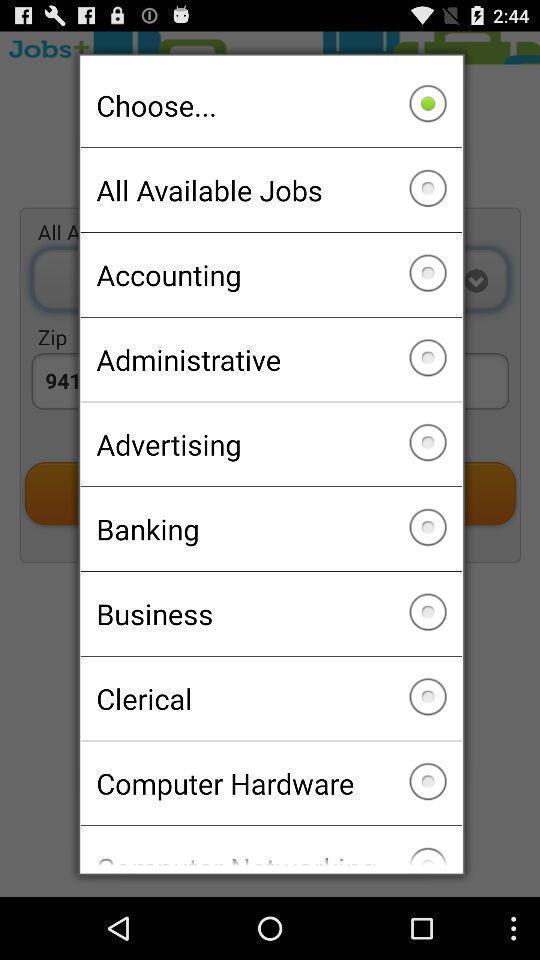Summarize the main components in this picture. Popup of different job types to choose. 